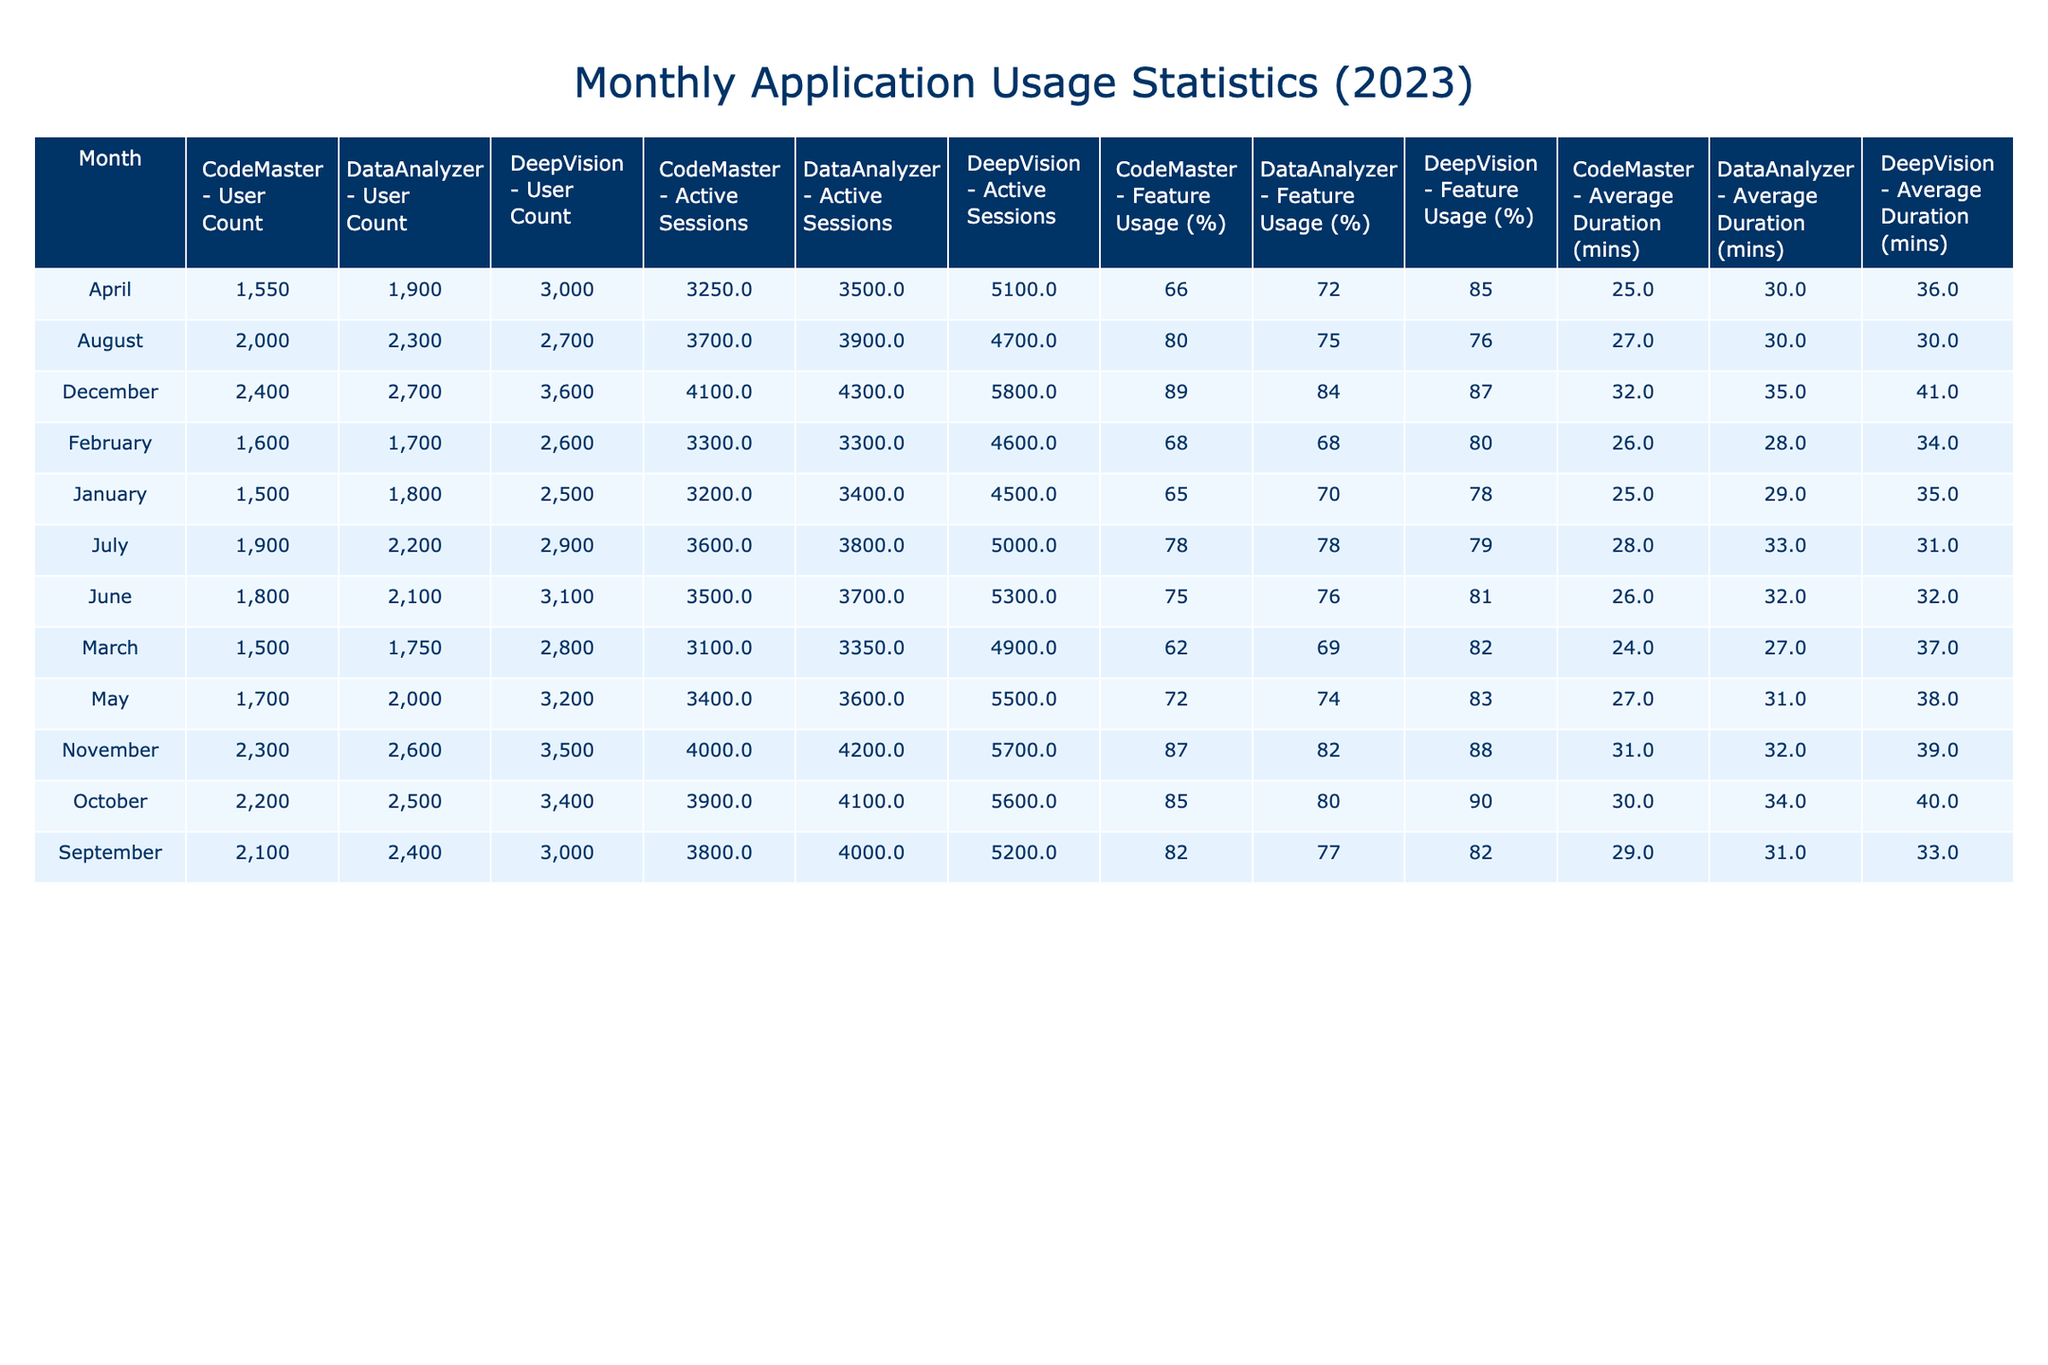What was the total user count for DeepVision in 2023? To find the total user count for DeepVision, I need to sum the user counts for each month: 2500 + 2600 + 2800 + 3000 + 3200 + 3100 + 2900 + 2700 + 3000 + 3400 + 3500 + 3600 = 35,700.
Answer: 35700 Which month had the highest average duration of sessions for CodeMaster? Looking at the average duration of sessions for CodeMaster, I find the maximum value was 32 minutes in December.
Answer: 32 minutes Did the feature usage percentage for DataAnalyzer increase every month? By checking the feature usage percentages for DataAnalyzer, I see they changed as follows: 70, 68, 69, 72, 74, 76, 78, 75, 77, 80, 82, 84. Since they decreased from January to February, the answer is no.
Answer: No What is the average feature usage percentage for all tools in October? To find the average feature usage percentage for October across all three tools, I will add their percentages: 90 (DeepVision) + 85 (CodeMaster) + 80 (DataAnalyzer) = 255. Then, I divide by 3, resulting in an average of 255 / 3 = 85.
Answer: 85 Which tool had the most active sessions in December? By examining the Active Sessions column for December, DeepVision shows 5800 sessions while CodeMaster has 4100 and DataAnalyzer has 4300. Therefore, DeepVision had the most active sessions in December.
Answer: DeepVision What was the percentage increase in user count from January to December for DataAnalyzer? To calculate the percentage increase in user count, I will subtract the January count (1800) from the December count (2700), which gives 2700 - 1800 = 900. Then, I divide by the January count (1800) and multiply by 100: (900 / 1800) * 100 = 50%.
Answer: 50% Which month had the highest user count for CodeMaster? Reviewing the user counts for CodeMaster, I find that December had the highest user count at 2400.
Answer: December If I combine the Active Sessions of all tools in September, what will the total be? First, I will sum the active sessions for September: DeepVision (5200) + CodeMaster (3800) + DataAnalyzer (4000) = 13000.
Answer: 13000 True or False: The feature usage percentage for DeepVision in April was higher than in May. Checking the feature usage percentages, April was 85% and May was 83%. Hence, it is true that it was higher in April than in May.
Answer: True In which month did CodeMaster see the smallest user count increase compared to the previous month? By examining the user count changes month by month for CodeMaster, I find the increases were: 100, -100, 50, 150, 100, 100, 100, 100, 100, 100. The smallest increase was -100 from March to February.
Answer: February What was the average duration of sessions for all tools across the year? To find the average duration for all tools, I'll sum their durations and divide by the total months. Total duration: (35 + 34 + 37 + 36 + 38 + 32 + 31 + 30 + 33 + 40 + 39 + 41 + 25 + 26 + 24 + 25 + 27 + 26 + 28 + 27 + 29 + 30 + 31 + 32 + 29 + 28 + 27 + 30 + 31 + 32 + 35) = 468. Dividing 468 by 36 (total number of entries) gives an average of 13.
Answer: 13 